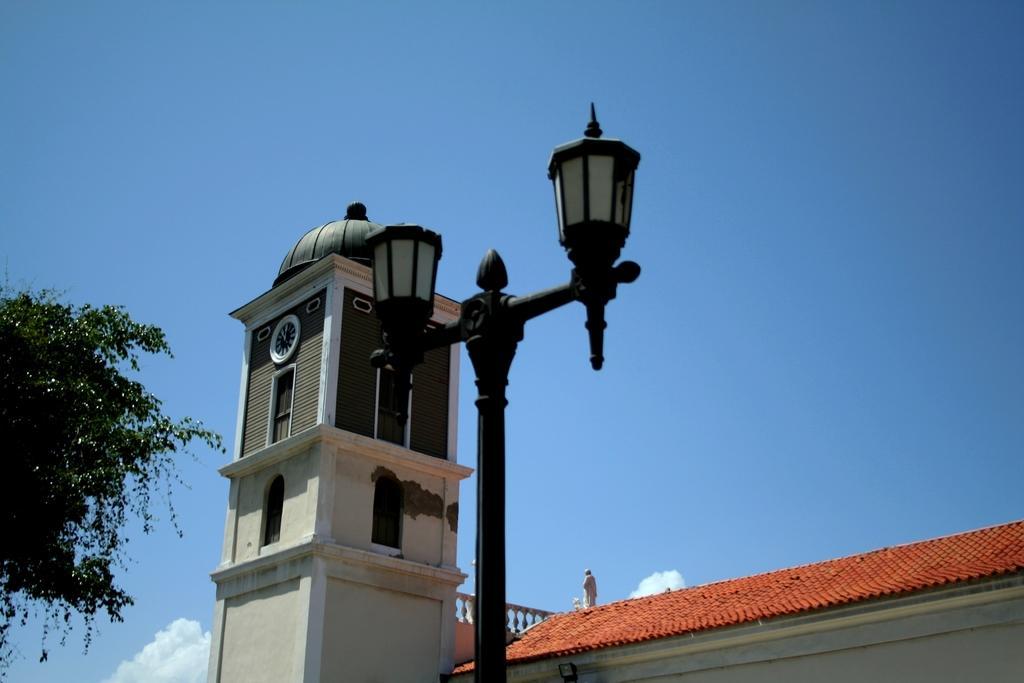How would you summarize this image in a sentence or two? To this pole there are lanterns lamps. Background there is a clock tower, statue, roof, tree and blue sky. To this clock tower there are windows and clock. 